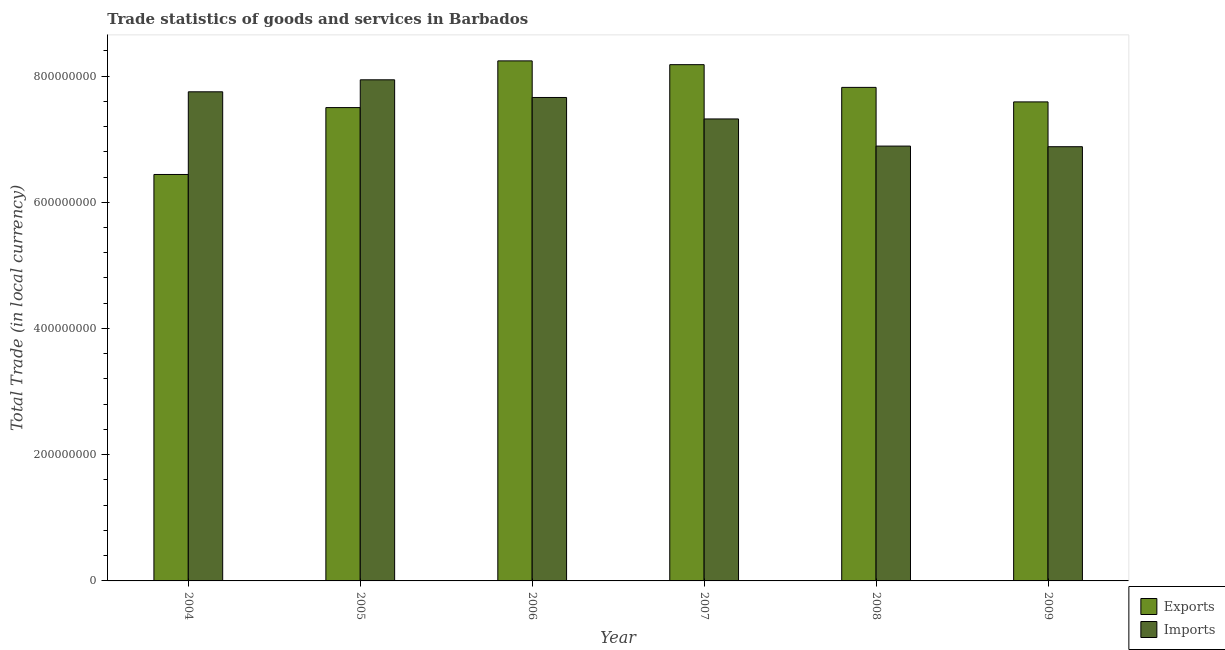How many different coloured bars are there?
Keep it short and to the point. 2. How many groups of bars are there?
Make the answer very short. 6. Are the number of bars per tick equal to the number of legend labels?
Offer a very short reply. Yes. What is the label of the 2nd group of bars from the left?
Your answer should be compact. 2005. In how many cases, is the number of bars for a given year not equal to the number of legend labels?
Offer a very short reply. 0. What is the imports of goods and services in 2009?
Provide a succinct answer. 6.88e+08. Across all years, what is the maximum imports of goods and services?
Keep it short and to the point. 7.94e+08. Across all years, what is the minimum export of goods and services?
Keep it short and to the point. 6.44e+08. In which year was the export of goods and services maximum?
Offer a terse response. 2006. What is the total export of goods and services in the graph?
Your answer should be compact. 4.58e+09. What is the difference between the export of goods and services in 2006 and that in 2009?
Offer a terse response. 6.50e+07. What is the difference between the export of goods and services in 2009 and the imports of goods and services in 2006?
Provide a succinct answer. -6.50e+07. What is the average imports of goods and services per year?
Give a very brief answer. 7.41e+08. In the year 2004, what is the difference between the export of goods and services and imports of goods and services?
Offer a very short reply. 0. What is the ratio of the export of goods and services in 2005 to that in 2008?
Give a very brief answer. 0.96. What is the difference between the highest and the second highest imports of goods and services?
Keep it short and to the point. 1.90e+07. What is the difference between the highest and the lowest export of goods and services?
Ensure brevity in your answer.  1.80e+08. Is the sum of the export of goods and services in 2007 and 2009 greater than the maximum imports of goods and services across all years?
Provide a short and direct response. Yes. What does the 2nd bar from the left in 2004 represents?
Your answer should be compact. Imports. What does the 1st bar from the right in 2004 represents?
Provide a succinct answer. Imports. Are all the bars in the graph horizontal?
Make the answer very short. No. Where does the legend appear in the graph?
Provide a short and direct response. Bottom right. What is the title of the graph?
Provide a succinct answer. Trade statistics of goods and services in Barbados. What is the label or title of the Y-axis?
Offer a very short reply. Total Trade (in local currency). What is the Total Trade (in local currency) of Exports in 2004?
Give a very brief answer. 6.44e+08. What is the Total Trade (in local currency) of Imports in 2004?
Provide a short and direct response. 7.75e+08. What is the Total Trade (in local currency) of Exports in 2005?
Offer a very short reply. 7.50e+08. What is the Total Trade (in local currency) in Imports in 2005?
Give a very brief answer. 7.94e+08. What is the Total Trade (in local currency) in Exports in 2006?
Your response must be concise. 8.24e+08. What is the Total Trade (in local currency) in Imports in 2006?
Provide a succinct answer. 7.66e+08. What is the Total Trade (in local currency) of Exports in 2007?
Provide a short and direct response. 8.18e+08. What is the Total Trade (in local currency) in Imports in 2007?
Your answer should be very brief. 7.32e+08. What is the Total Trade (in local currency) in Exports in 2008?
Your answer should be compact. 7.82e+08. What is the Total Trade (in local currency) in Imports in 2008?
Your answer should be compact. 6.89e+08. What is the Total Trade (in local currency) of Exports in 2009?
Make the answer very short. 7.59e+08. What is the Total Trade (in local currency) of Imports in 2009?
Ensure brevity in your answer.  6.88e+08. Across all years, what is the maximum Total Trade (in local currency) in Exports?
Your response must be concise. 8.24e+08. Across all years, what is the maximum Total Trade (in local currency) of Imports?
Ensure brevity in your answer.  7.94e+08. Across all years, what is the minimum Total Trade (in local currency) of Exports?
Make the answer very short. 6.44e+08. Across all years, what is the minimum Total Trade (in local currency) of Imports?
Provide a short and direct response. 6.88e+08. What is the total Total Trade (in local currency) in Exports in the graph?
Ensure brevity in your answer.  4.58e+09. What is the total Total Trade (in local currency) in Imports in the graph?
Offer a very short reply. 4.44e+09. What is the difference between the Total Trade (in local currency) in Exports in 2004 and that in 2005?
Provide a succinct answer. -1.06e+08. What is the difference between the Total Trade (in local currency) of Imports in 2004 and that in 2005?
Make the answer very short. -1.90e+07. What is the difference between the Total Trade (in local currency) of Exports in 2004 and that in 2006?
Keep it short and to the point. -1.80e+08. What is the difference between the Total Trade (in local currency) of Imports in 2004 and that in 2006?
Offer a terse response. 9.00e+06. What is the difference between the Total Trade (in local currency) in Exports in 2004 and that in 2007?
Offer a very short reply. -1.74e+08. What is the difference between the Total Trade (in local currency) in Imports in 2004 and that in 2007?
Provide a short and direct response. 4.30e+07. What is the difference between the Total Trade (in local currency) in Exports in 2004 and that in 2008?
Provide a succinct answer. -1.38e+08. What is the difference between the Total Trade (in local currency) of Imports in 2004 and that in 2008?
Your answer should be compact. 8.60e+07. What is the difference between the Total Trade (in local currency) in Exports in 2004 and that in 2009?
Ensure brevity in your answer.  -1.15e+08. What is the difference between the Total Trade (in local currency) of Imports in 2004 and that in 2009?
Your answer should be compact. 8.70e+07. What is the difference between the Total Trade (in local currency) of Exports in 2005 and that in 2006?
Offer a terse response. -7.40e+07. What is the difference between the Total Trade (in local currency) in Imports in 2005 and that in 2006?
Your answer should be very brief. 2.80e+07. What is the difference between the Total Trade (in local currency) of Exports in 2005 and that in 2007?
Make the answer very short. -6.80e+07. What is the difference between the Total Trade (in local currency) of Imports in 2005 and that in 2007?
Your answer should be very brief. 6.20e+07. What is the difference between the Total Trade (in local currency) in Exports in 2005 and that in 2008?
Provide a succinct answer. -3.20e+07. What is the difference between the Total Trade (in local currency) in Imports in 2005 and that in 2008?
Offer a very short reply. 1.05e+08. What is the difference between the Total Trade (in local currency) in Exports in 2005 and that in 2009?
Make the answer very short. -9.00e+06. What is the difference between the Total Trade (in local currency) in Imports in 2005 and that in 2009?
Your response must be concise. 1.06e+08. What is the difference between the Total Trade (in local currency) in Imports in 2006 and that in 2007?
Give a very brief answer. 3.40e+07. What is the difference between the Total Trade (in local currency) in Exports in 2006 and that in 2008?
Keep it short and to the point. 4.20e+07. What is the difference between the Total Trade (in local currency) in Imports in 2006 and that in 2008?
Make the answer very short. 7.70e+07. What is the difference between the Total Trade (in local currency) of Exports in 2006 and that in 2009?
Your answer should be very brief. 6.50e+07. What is the difference between the Total Trade (in local currency) in Imports in 2006 and that in 2009?
Offer a terse response. 7.80e+07. What is the difference between the Total Trade (in local currency) in Exports in 2007 and that in 2008?
Provide a succinct answer. 3.60e+07. What is the difference between the Total Trade (in local currency) in Imports in 2007 and that in 2008?
Offer a very short reply. 4.30e+07. What is the difference between the Total Trade (in local currency) of Exports in 2007 and that in 2009?
Offer a terse response. 5.90e+07. What is the difference between the Total Trade (in local currency) in Imports in 2007 and that in 2009?
Offer a terse response. 4.40e+07. What is the difference between the Total Trade (in local currency) in Exports in 2008 and that in 2009?
Make the answer very short. 2.30e+07. What is the difference between the Total Trade (in local currency) of Imports in 2008 and that in 2009?
Give a very brief answer. 1.00e+06. What is the difference between the Total Trade (in local currency) of Exports in 2004 and the Total Trade (in local currency) of Imports in 2005?
Ensure brevity in your answer.  -1.50e+08. What is the difference between the Total Trade (in local currency) in Exports in 2004 and the Total Trade (in local currency) in Imports in 2006?
Offer a terse response. -1.22e+08. What is the difference between the Total Trade (in local currency) of Exports in 2004 and the Total Trade (in local currency) of Imports in 2007?
Provide a short and direct response. -8.80e+07. What is the difference between the Total Trade (in local currency) in Exports in 2004 and the Total Trade (in local currency) in Imports in 2008?
Your response must be concise. -4.50e+07. What is the difference between the Total Trade (in local currency) in Exports in 2004 and the Total Trade (in local currency) in Imports in 2009?
Your answer should be compact. -4.40e+07. What is the difference between the Total Trade (in local currency) in Exports in 2005 and the Total Trade (in local currency) in Imports in 2006?
Provide a succinct answer. -1.60e+07. What is the difference between the Total Trade (in local currency) in Exports in 2005 and the Total Trade (in local currency) in Imports in 2007?
Your answer should be very brief. 1.80e+07. What is the difference between the Total Trade (in local currency) in Exports in 2005 and the Total Trade (in local currency) in Imports in 2008?
Make the answer very short. 6.10e+07. What is the difference between the Total Trade (in local currency) in Exports in 2005 and the Total Trade (in local currency) in Imports in 2009?
Provide a succinct answer. 6.20e+07. What is the difference between the Total Trade (in local currency) in Exports in 2006 and the Total Trade (in local currency) in Imports in 2007?
Your response must be concise. 9.20e+07. What is the difference between the Total Trade (in local currency) in Exports in 2006 and the Total Trade (in local currency) in Imports in 2008?
Provide a short and direct response. 1.35e+08. What is the difference between the Total Trade (in local currency) in Exports in 2006 and the Total Trade (in local currency) in Imports in 2009?
Offer a very short reply. 1.36e+08. What is the difference between the Total Trade (in local currency) of Exports in 2007 and the Total Trade (in local currency) of Imports in 2008?
Make the answer very short. 1.29e+08. What is the difference between the Total Trade (in local currency) of Exports in 2007 and the Total Trade (in local currency) of Imports in 2009?
Your answer should be very brief. 1.30e+08. What is the difference between the Total Trade (in local currency) in Exports in 2008 and the Total Trade (in local currency) in Imports in 2009?
Your answer should be compact. 9.40e+07. What is the average Total Trade (in local currency) of Exports per year?
Make the answer very short. 7.63e+08. What is the average Total Trade (in local currency) of Imports per year?
Offer a terse response. 7.41e+08. In the year 2004, what is the difference between the Total Trade (in local currency) of Exports and Total Trade (in local currency) of Imports?
Provide a succinct answer. -1.31e+08. In the year 2005, what is the difference between the Total Trade (in local currency) of Exports and Total Trade (in local currency) of Imports?
Keep it short and to the point. -4.40e+07. In the year 2006, what is the difference between the Total Trade (in local currency) of Exports and Total Trade (in local currency) of Imports?
Your answer should be very brief. 5.80e+07. In the year 2007, what is the difference between the Total Trade (in local currency) of Exports and Total Trade (in local currency) of Imports?
Keep it short and to the point. 8.60e+07. In the year 2008, what is the difference between the Total Trade (in local currency) in Exports and Total Trade (in local currency) in Imports?
Ensure brevity in your answer.  9.30e+07. In the year 2009, what is the difference between the Total Trade (in local currency) in Exports and Total Trade (in local currency) in Imports?
Ensure brevity in your answer.  7.10e+07. What is the ratio of the Total Trade (in local currency) in Exports in 2004 to that in 2005?
Provide a succinct answer. 0.86. What is the ratio of the Total Trade (in local currency) in Imports in 2004 to that in 2005?
Provide a succinct answer. 0.98. What is the ratio of the Total Trade (in local currency) of Exports in 2004 to that in 2006?
Make the answer very short. 0.78. What is the ratio of the Total Trade (in local currency) of Imports in 2004 to that in 2006?
Provide a succinct answer. 1.01. What is the ratio of the Total Trade (in local currency) in Exports in 2004 to that in 2007?
Offer a terse response. 0.79. What is the ratio of the Total Trade (in local currency) of Imports in 2004 to that in 2007?
Ensure brevity in your answer.  1.06. What is the ratio of the Total Trade (in local currency) in Exports in 2004 to that in 2008?
Keep it short and to the point. 0.82. What is the ratio of the Total Trade (in local currency) of Imports in 2004 to that in 2008?
Give a very brief answer. 1.12. What is the ratio of the Total Trade (in local currency) of Exports in 2004 to that in 2009?
Provide a succinct answer. 0.85. What is the ratio of the Total Trade (in local currency) in Imports in 2004 to that in 2009?
Your answer should be compact. 1.13. What is the ratio of the Total Trade (in local currency) of Exports in 2005 to that in 2006?
Offer a terse response. 0.91. What is the ratio of the Total Trade (in local currency) of Imports in 2005 to that in 2006?
Offer a terse response. 1.04. What is the ratio of the Total Trade (in local currency) in Exports in 2005 to that in 2007?
Your answer should be very brief. 0.92. What is the ratio of the Total Trade (in local currency) in Imports in 2005 to that in 2007?
Offer a terse response. 1.08. What is the ratio of the Total Trade (in local currency) in Exports in 2005 to that in 2008?
Offer a very short reply. 0.96. What is the ratio of the Total Trade (in local currency) of Imports in 2005 to that in 2008?
Ensure brevity in your answer.  1.15. What is the ratio of the Total Trade (in local currency) of Exports in 2005 to that in 2009?
Provide a succinct answer. 0.99. What is the ratio of the Total Trade (in local currency) in Imports in 2005 to that in 2009?
Offer a terse response. 1.15. What is the ratio of the Total Trade (in local currency) of Exports in 2006 to that in 2007?
Ensure brevity in your answer.  1.01. What is the ratio of the Total Trade (in local currency) in Imports in 2006 to that in 2007?
Give a very brief answer. 1.05. What is the ratio of the Total Trade (in local currency) in Exports in 2006 to that in 2008?
Your answer should be compact. 1.05. What is the ratio of the Total Trade (in local currency) in Imports in 2006 to that in 2008?
Offer a very short reply. 1.11. What is the ratio of the Total Trade (in local currency) of Exports in 2006 to that in 2009?
Your answer should be very brief. 1.09. What is the ratio of the Total Trade (in local currency) of Imports in 2006 to that in 2009?
Offer a very short reply. 1.11. What is the ratio of the Total Trade (in local currency) of Exports in 2007 to that in 2008?
Offer a terse response. 1.05. What is the ratio of the Total Trade (in local currency) of Imports in 2007 to that in 2008?
Provide a succinct answer. 1.06. What is the ratio of the Total Trade (in local currency) in Exports in 2007 to that in 2009?
Your response must be concise. 1.08. What is the ratio of the Total Trade (in local currency) in Imports in 2007 to that in 2009?
Offer a very short reply. 1.06. What is the ratio of the Total Trade (in local currency) of Exports in 2008 to that in 2009?
Provide a succinct answer. 1.03. What is the ratio of the Total Trade (in local currency) in Imports in 2008 to that in 2009?
Offer a terse response. 1. What is the difference between the highest and the second highest Total Trade (in local currency) in Exports?
Your answer should be very brief. 6.00e+06. What is the difference between the highest and the second highest Total Trade (in local currency) of Imports?
Your answer should be compact. 1.90e+07. What is the difference between the highest and the lowest Total Trade (in local currency) in Exports?
Provide a succinct answer. 1.80e+08. What is the difference between the highest and the lowest Total Trade (in local currency) of Imports?
Your response must be concise. 1.06e+08. 